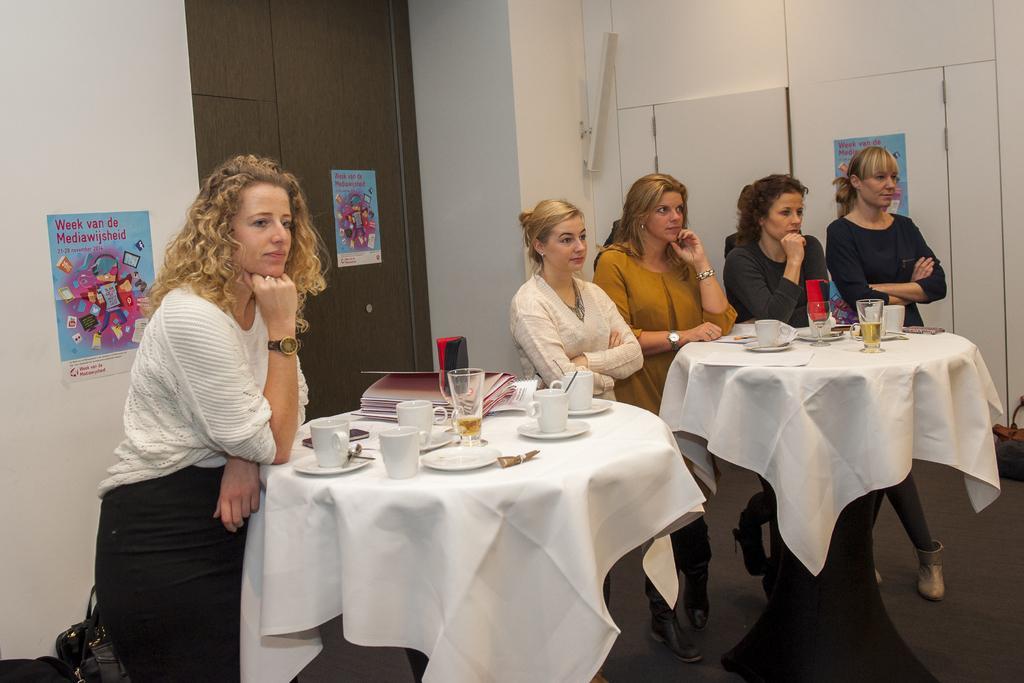Please provide a concise description of this image. In this image i can see 5 women standing in front of a table, on the table i can see few cups, papers, a glass and a mobile. In the background i can see a wall, a door and few posts attached to the wall. 